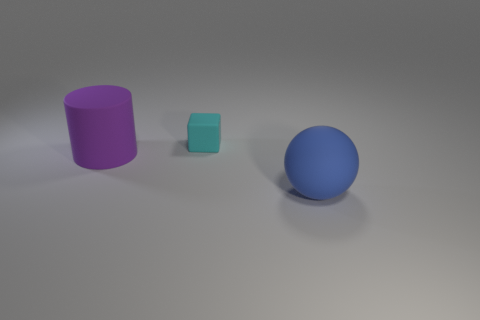Is there any other thing that has the same size as the matte sphere?
Ensure brevity in your answer.  Yes. What number of objects are either blue spheres or tiny blue objects?
Provide a short and direct response. 1. There is a cyan thing that is made of the same material as the purple cylinder; what is its shape?
Your answer should be compact. Cube. How big is the object that is in front of the big object that is left of the large ball?
Offer a very short reply. Large. How many small objects are either cyan objects or blue metal cylinders?
Your answer should be very brief. 1. How many other things are the same color as the large rubber sphere?
Provide a short and direct response. 0. Is the size of the object that is in front of the purple thing the same as the rubber object that is behind the purple rubber object?
Your answer should be compact. No. Is the cube made of the same material as the thing that is in front of the purple rubber cylinder?
Your answer should be compact. Yes. Is the number of large purple cylinders that are behind the blue ball greater than the number of matte blocks that are behind the cyan object?
Your answer should be very brief. Yes. There is a thing that is behind the large object to the left of the blue rubber thing; what is its color?
Provide a short and direct response. Cyan. 